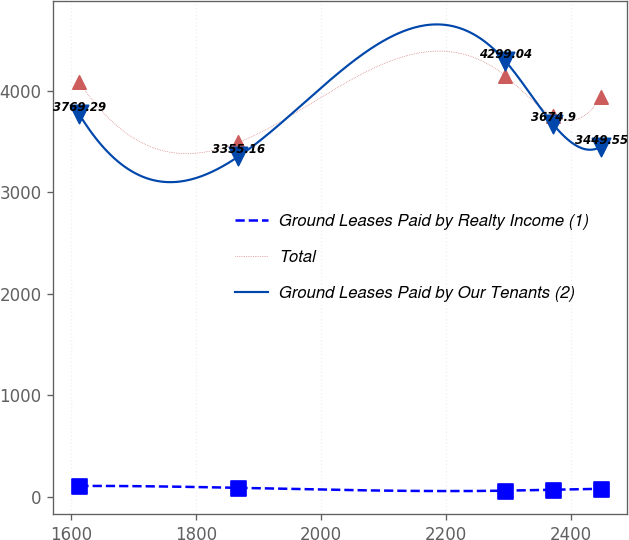Convert chart to OTSL. <chart><loc_0><loc_0><loc_500><loc_500><line_chart><ecel><fcel>Ground Leases Paid by Realty Income (1)<fcel>Total<fcel>Ground Leases Paid by Our Tenants (2)<nl><fcel>1612.65<fcel>104.75<fcel>4086.42<fcel>3769.29<nl><fcel>1867.72<fcel>85.89<fcel>3493.92<fcel>3355.16<nl><fcel>2295.09<fcel>58.09<fcel>4151.27<fcel>4299.04<nl><fcel>2371.71<fcel>67.58<fcel>3757.98<fcel>3674.9<nl><fcel>2448.33<fcel>76.46<fcel>3941.23<fcel>3449.55<nl></chart> 